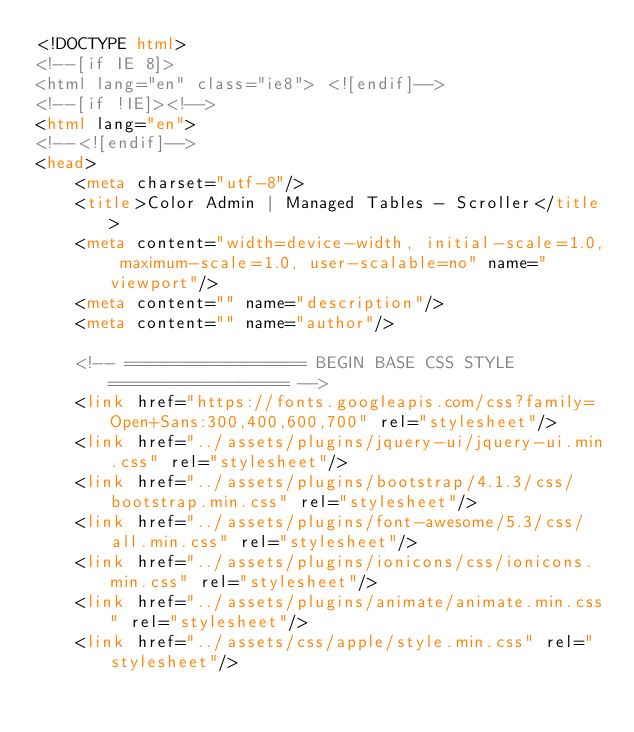Convert code to text. <code><loc_0><loc_0><loc_500><loc_500><_HTML_><!DOCTYPE html>
<!--[if IE 8]>
<html lang="en" class="ie8"> <![endif]-->
<!--[if !IE]><!-->
<html lang="en">
<!--<![endif]-->
<head>
    <meta charset="utf-8"/>
    <title>Color Admin | Managed Tables - Scroller</title>
    <meta content="width=device-width, initial-scale=1.0, maximum-scale=1.0, user-scalable=no" name="viewport"/>
    <meta content="" name="description"/>
    <meta content="" name="author"/>

    <!-- ================== BEGIN BASE CSS STYLE ================== -->
    <link href="https://fonts.googleapis.com/css?family=Open+Sans:300,400,600,700" rel="stylesheet"/>
    <link href="../assets/plugins/jquery-ui/jquery-ui.min.css" rel="stylesheet"/>
    <link href="../assets/plugins/bootstrap/4.1.3/css/bootstrap.min.css" rel="stylesheet"/>
    <link href="../assets/plugins/font-awesome/5.3/css/all.min.css" rel="stylesheet"/>
    <link href="../assets/plugins/ionicons/css/ionicons.min.css" rel="stylesheet"/>
    <link href="../assets/plugins/animate/animate.min.css" rel="stylesheet"/>
    <link href="../assets/css/apple/style.min.css" rel="stylesheet"/></code> 